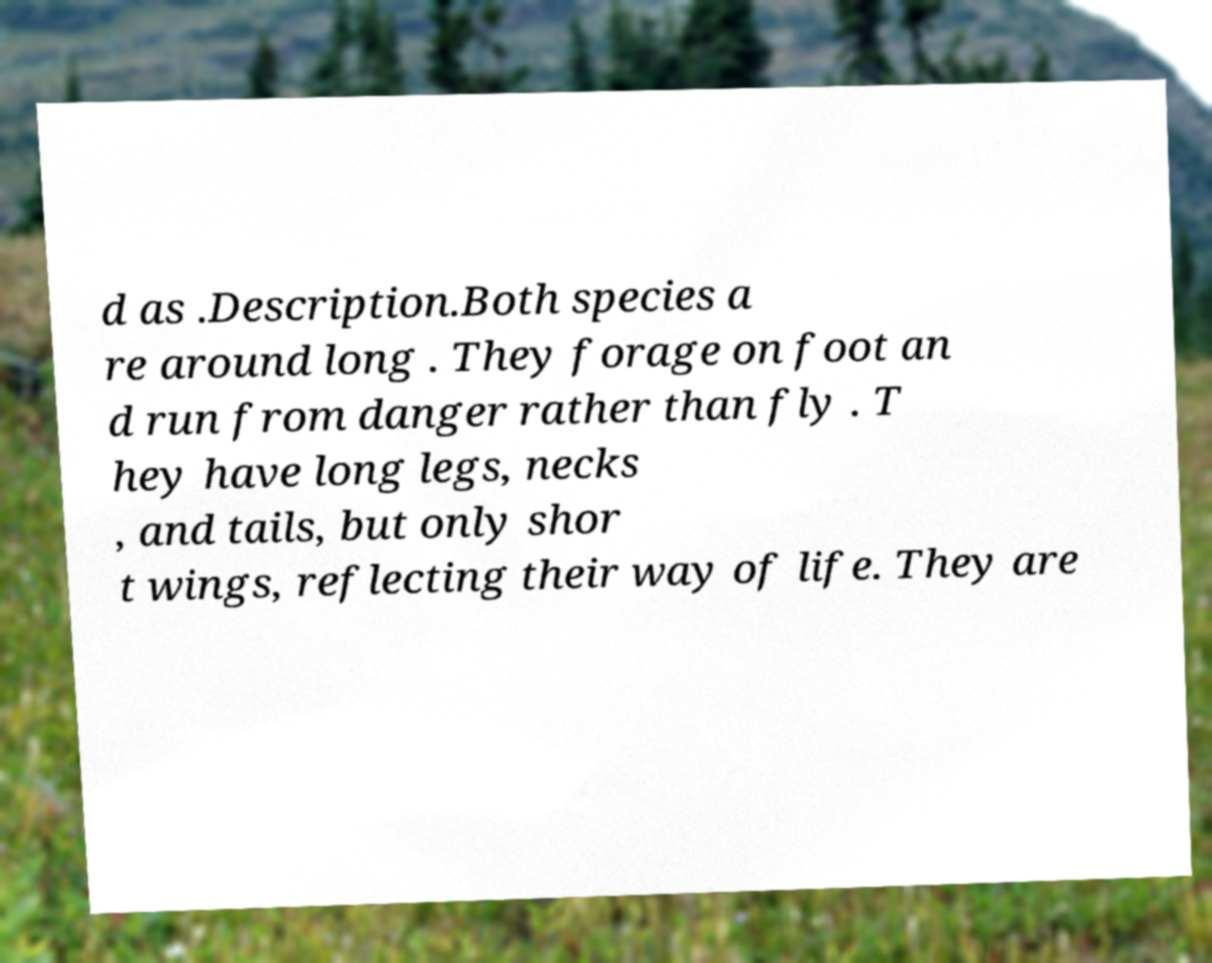There's text embedded in this image that I need extracted. Can you transcribe it verbatim? d as .Description.Both species a re around long . They forage on foot an d run from danger rather than fly . T hey have long legs, necks , and tails, but only shor t wings, reflecting their way of life. They are 